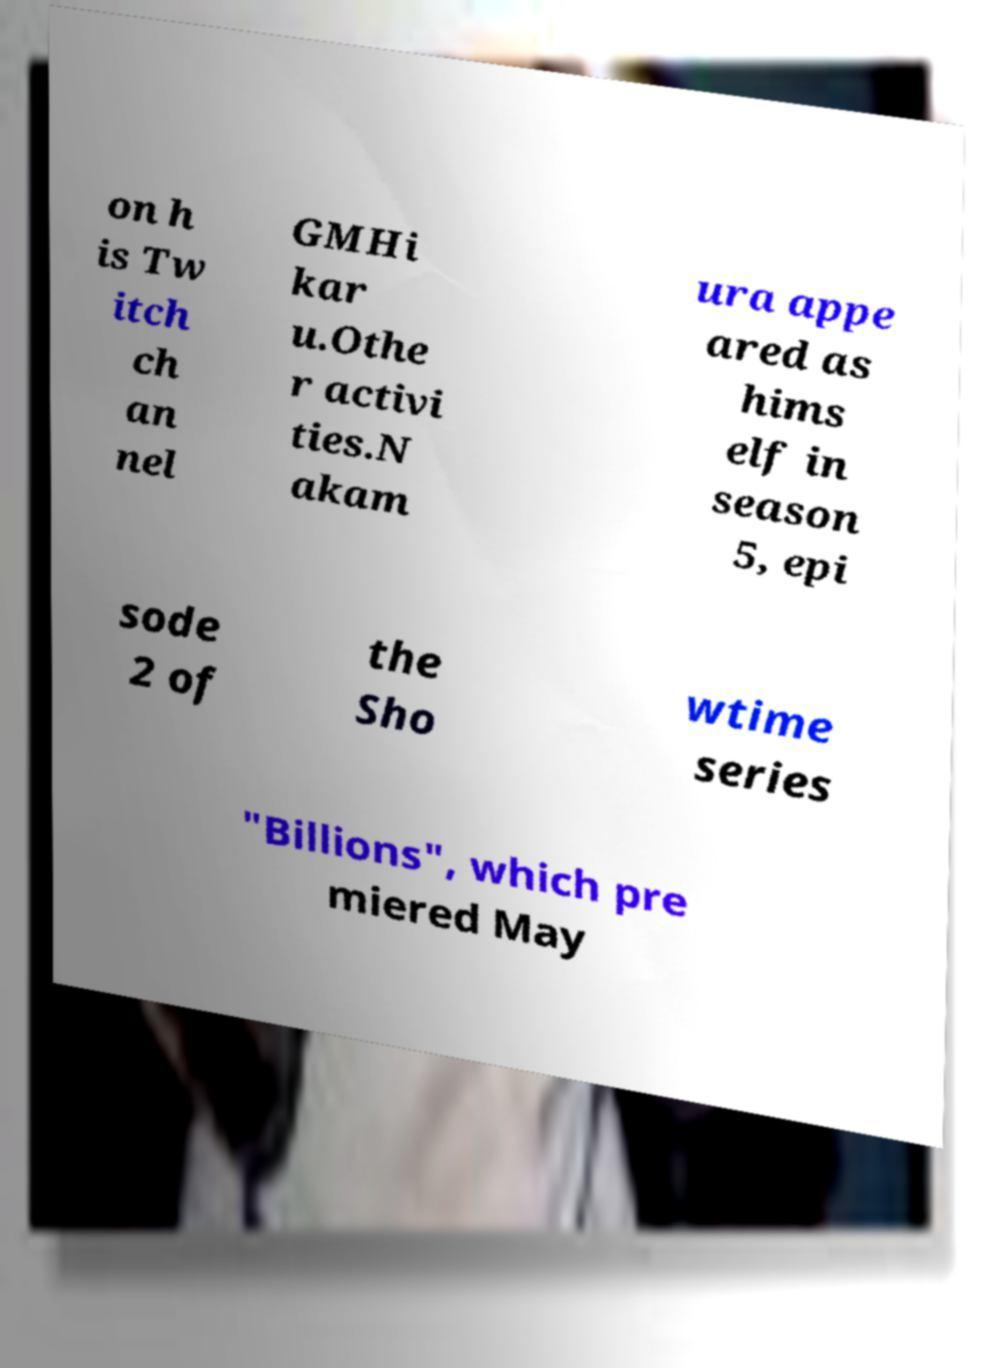Could you extract and type out the text from this image? on h is Tw itch ch an nel GMHi kar u.Othe r activi ties.N akam ura appe ared as hims elf in season 5, epi sode 2 of the Sho wtime series "Billions", which pre miered May 